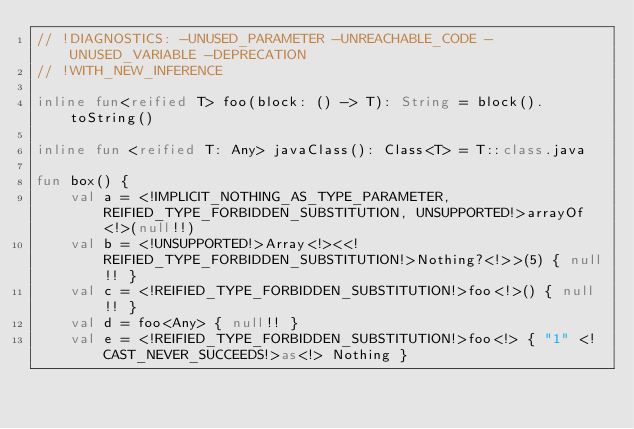Convert code to text. <code><loc_0><loc_0><loc_500><loc_500><_Kotlin_>// !DIAGNOSTICS: -UNUSED_PARAMETER -UNREACHABLE_CODE -UNUSED_VARIABLE -DEPRECATION
// !WITH_NEW_INFERENCE

inline fun<reified T> foo(block: () -> T): String = block().toString()

inline fun <reified T: Any> javaClass(): Class<T> = T::class.java

fun box() {
    val a = <!IMPLICIT_NOTHING_AS_TYPE_PARAMETER, REIFIED_TYPE_FORBIDDEN_SUBSTITUTION, UNSUPPORTED!>arrayOf<!>(null!!)
    val b = <!UNSUPPORTED!>Array<!><<!REIFIED_TYPE_FORBIDDEN_SUBSTITUTION!>Nothing?<!>>(5) { null!! }
    val c = <!REIFIED_TYPE_FORBIDDEN_SUBSTITUTION!>foo<!>() { null!! }
    val d = foo<Any> { null!! }
    val e = <!REIFIED_TYPE_FORBIDDEN_SUBSTITUTION!>foo<!> { "1" <!CAST_NEVER_SUCCEEDS!>as<!> Nothing }</code> 